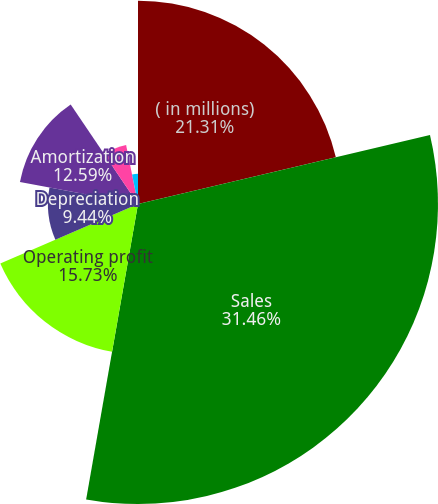<chart> <loc_0><loc_0><loc_500><loc_500><pie_chart><fcel>( in millions)<fcel>Sales<fcel>Operating profit<fcel>Depreciation<fcel>Amortization<fcel>Operating profit as a of sales<fcel>Depreciation as a of sales<fcel>Amortization as a of sales<nl><fcel>21.31%<fcel>31.45%<fcel>15.73%<fcel>9.44%<fcel>12.59%<fcel>6.3%<fcel>0.01%<fcel>3.16%<nl></chart> 